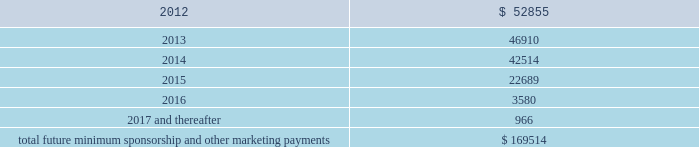Operating lease agreements .
Included in these amounts was contingent rent expense of $ 3.6 million , $ 2.0 million and $ 0.6 million for the years ended december 31 , 2011 , 2010 and 2009 , respectively .
The operating lease obligations included above do not include any contingent rent .
Sponsorships and other marketing commitments within the normal course of business , the company enters into contractual commitments in order to promote the company 2019s brand and products .
These commitments include sponsorship agreements with teams and athletes on the collegiate and professional levels , official supplier agreements , athletic event sponsorships and other marketing commitments .
The following is a schedule of the company 2019s future minimum payments under its sponsorship and other marketing agreements as of december 31 , 2011 : ( in thousands ) .
The amounts listed above are the minimum obligations required to be paid under the company 2019s sponsorship and other marketing agreements .
The amounts listed above do not include additional performance incentives and product supply obligations provided under certain agreements .
It is not possible to determine how much the company will spend on product supply obligations on an annual basis as contracts generally do not stipulate specific cash amounts to be spent on products .
The amount of product provided to the sponsorships depends on many factors including general playing conditions , the number of sporting events in which they participate and the company 2019s decisions regarding product and marketing initiatives .
In addition , the costs to design , develop , source and purchase the products furnished to the endorsers are incurred over a period of time and are not necessarily tracked separately from similar costs incurred for products sold to customers .
The company is , from time to time , involved in routine legal matters incidental to its business .
The company believes that the ultimate resolution of any such current proceedings and claims will not have a material adverse effect on its consolidated financial position , results of operations or cash flows .
In connection with various contracts and agreements , the company has agreed to indemnify counterparties against certain third party claims relating to the infringement of intellectual property rights and other items .
Generally , such indemnification obligations do not apply in situations in which the counterparties are grossly negligent , engage in willful misconduct , or act in bad faith .
Based on the company 2019s historical experience and the estimated probability of future loss , the company has determined that the fair value of such indemnifications is not material to its consolidated financial position or results of operations .
Stockholders 2019 equity the company 2019s class a common stock and class b convertible common stock have an authorized number of shares of 100.0 million shares and 11.3 million shares , respectively , and each have a par value of $ 0.0003 1/3 per share .
Holders of class a common stock and class b convertible common stock have identical rights , including liquidation preferences , except that the holders of class a common stock are entitled to one vote per share and holders of class b convertible common stock are entitled to 10 votes per share on all matters submitted to a stockholder vote .
Class b convertible common stock may only be held by kevin plank .
What was the percentage increase the contingent rent expense from 2010 to 2011? 
Rationale: the contingent rent expense increased by 80% from 2010 to 2011
Computations: ((3.6 - 2.0) / 2.0)
Answer: 0.8. 